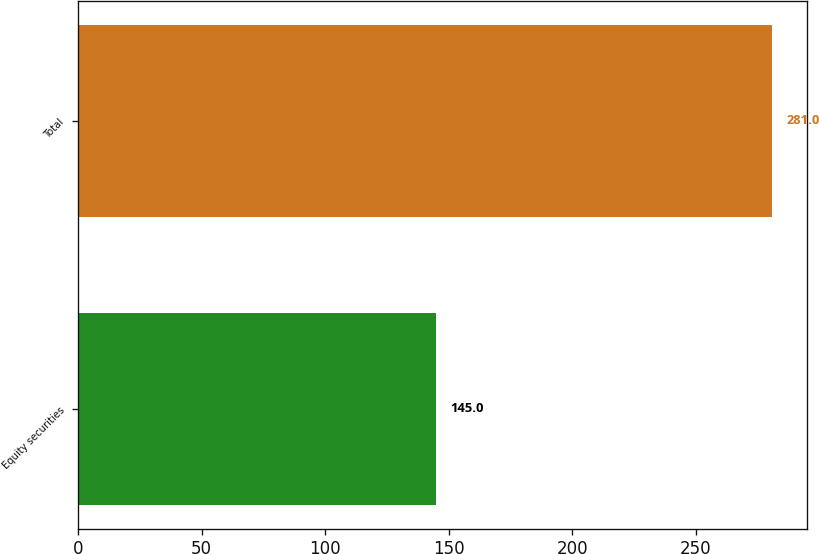Convert chart to OTSL. <chart><loc_0><loc_0><loc_500><loc_500><bar_chart><fcel>Equity securities<fcel>Total<nl><fcel>145<fcel>281<nl></chart> 